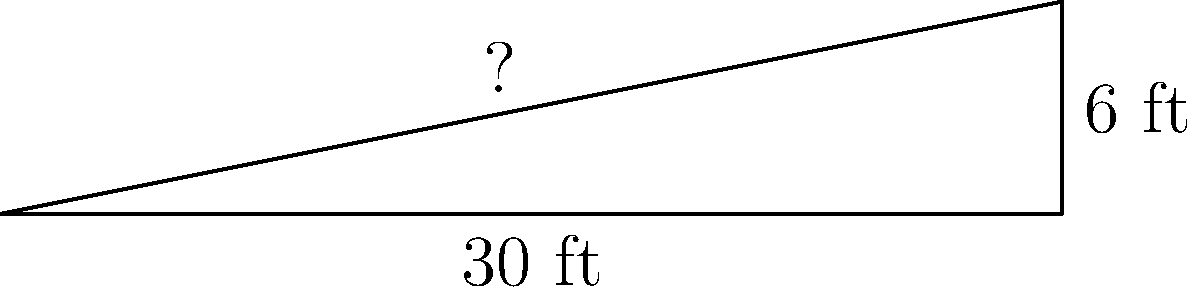As a youth sports coach, you're consulted on the design of a new accessible ramp for the basketball complex. The ramp needs to rise 6 feet over a horizontal distance of 30 feet. What is the slope of this ramp, and does it meet the ADA (Americans with Disabilities Act) requirement of a maximum 1:12 slope for accessibility? To solve this problem, we'll follow these steps:

1. Calculate the slope of the ramp:
   Slope = Rise / Run
   $\text{Slope} = \frac{\text{Rise}}{\text{Run}} = \frac{6 \text{ ft}}{30 \text{ ft}} = \frac{1}{5} = 0.2$

2. Convert the slope to a ratio:
   $0.2 = \frac{1}{5} = 1:5$

3. Compare to ADA requirements:
   ADA maximum slope = 1:12
   Our ramp slope = 1:5

4. Check if the ramp meets ADA requirements:
   1:5 is steeper than 1:12, so the ramp does not meet ADA requirements.

5. Calculate the correct length to meet ADA requirements:
   For a 1:12 slope: $\frac{6 \text{ ft}}{x} = \frac{1}{12}$
   Solving for x: $x = 6 \text{ ft} \times 12 = 72 \text{ ft}$

Therefore, the ramp has a slope of 1:5 or 0.2, which does not meet ADA requirements. To comply with ADA, the ramp would need to be extended to 72 feet in length.
Answer: Slope: 1:5; Does not meet ADA requirements 